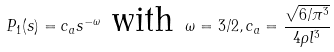<formula> <loc_0><loc_0><loc_500><loc_500>P _ { 1 } ( s ) = c _ { a } s ^ { - \omega } \text { with } \omega = 3 / 2 , c _ { a } = \frac { \sqrt { 6 / \pi ^ { 3 } } } { 4 \rho l ^ { 3 } }</formula> 